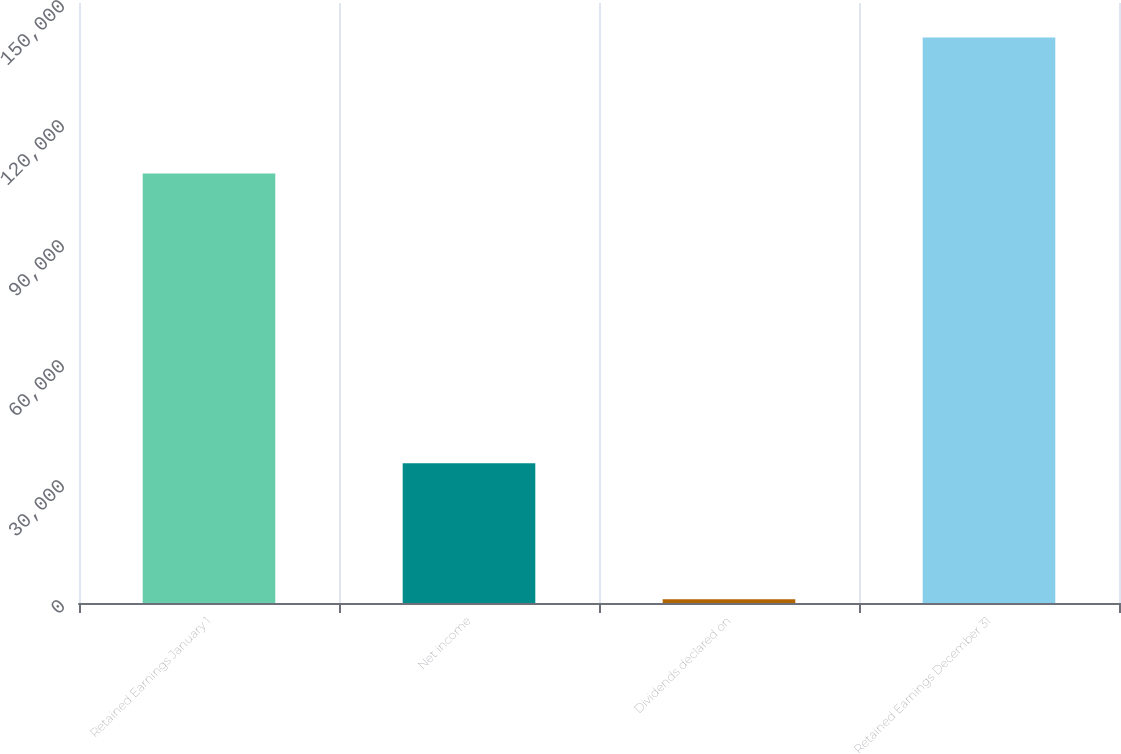Convert chart to OTSL. <chart><loc_0><loc_0><loc_500><loc_500><bar_chart><fcel>Retained Earnings January 1<fcel>Net income<fcel>Dividends declared on<fcel>Retained Earnings December 31<nl><fcel>107406<fcel>34947<fcel>965<fcel>141388<nl></chart> 